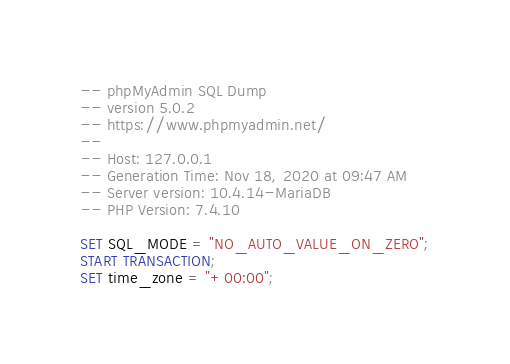Convert code to text. <code><loc_0><loc_0><loc_500><loc_500><_SQL_>-- phpMyAdmin SQL Dump
-- version 5.0.2
-- https://www.phpmyadmin.net/
--
-- Host: 127.0.0.1
-- Generation Time: Nov 18, 2020 at 09:47 AM
-- Server version: 10.4.14-MariaDB
-- PHP Version: 7.4.10

SET SQL_MODE = "NO_AUTO_VALUE_ON_ZERO";
START TRANSACTION;
SET time_zone = "+00:00";

</code> 